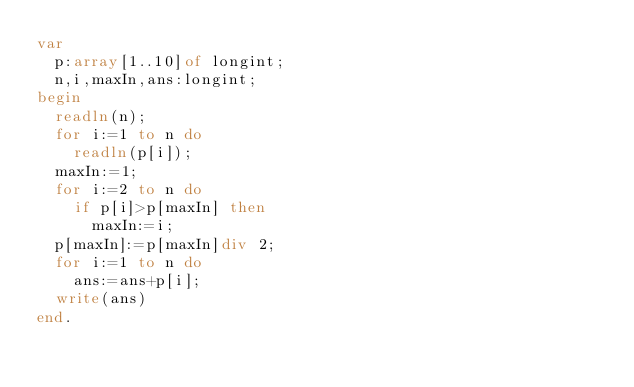Convert code to text. <code><loc_0><loc_0><loc_500><loc_500><_Pascal_>var
  p:array[1..10]of longint;
  n,i,maxIn,ans:longint;
begin
  readln(n);
  for i:=1 to n do
    readln(p[i]);
  maxIn:=1;
  for i:=2 to n do
    if p[i]>p[maxIn] then
      maxIn:=i;
  p[maxIn]:=p[maxIn]div 2;
  for i:=1 to n do
    ans:=ans+p[i];
  write(ans)
end.</code> 